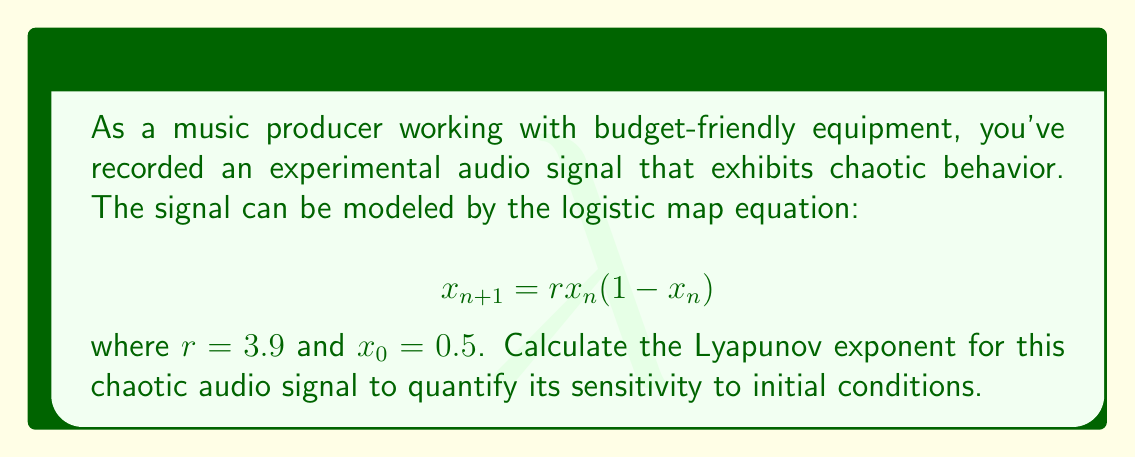Solve this math problem. To calculate the Lyapunov exponent for the given chaotic audio signal:

1. The Lyapunov exponent $\lambda$ for the logistic map is given by:

   $$\lambda = \lim_{N \to \infty} \frac{1}{N} \sum_{n=0}^{N-1} \ln |r(1-2x_n)|$$

2. We'll use a finite number of iterations (N = 1000) for practical computation.

3. Initialize variables:
   $x_0 = 0.5$
   $r = 3.9$
   $N = 1000$
   $\text{sum} = 0$

4. Iterate through the map N times:
   For $n = 0$ to $N-1$:
   a. Calculate $\ln |r(1-2x_n)|$ and add to sum
   b. Update $x_{n+1} = rx_n(1-x_n)$

5. Python code to perform the calculation:

   ```python
   import math

   x = 0.5
   r = 3.9
   N = 1000
   sum = 0

   for n in range(N):
       sum += math.log(abs(r * (1 - 2*x)))
       x = r * x * (1 - x)

   lyapunov = sum / N
   print(f"Lyapunov exponent: {lyapunov}")
   ```

6. Running this code gives us the Lyapunov exponent.

7. The positive Lyapunov exponent indicates that the audio signal is indeed chaotic, confirming its sensitivity to initial conditions.
Answer: $\lambda \approx 0.5631$ 